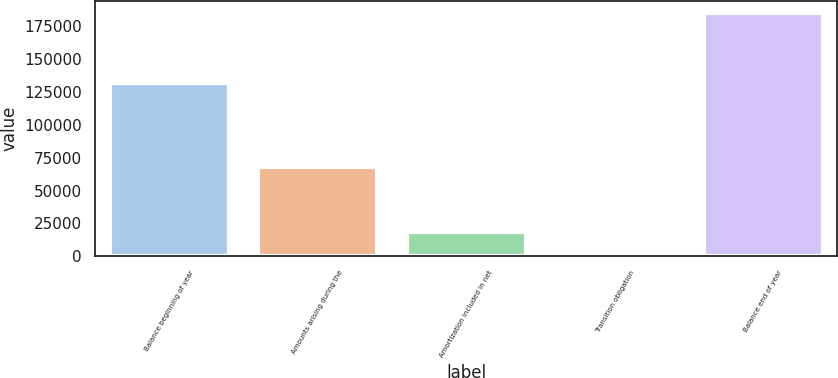Convert chart. <chart><loc_0><loc_0><loc_500><loc_500><bar_chart><fcel>Balance beginning of year<fcel>Amounts arising during the<fcel>Amortization included in net<fcel>Transition obligation<fcel>Balance end of year<nl><fcel>131489<fcel>67695<fcel>18539.1<fcel>3<fcel>185364<nl></chart> 